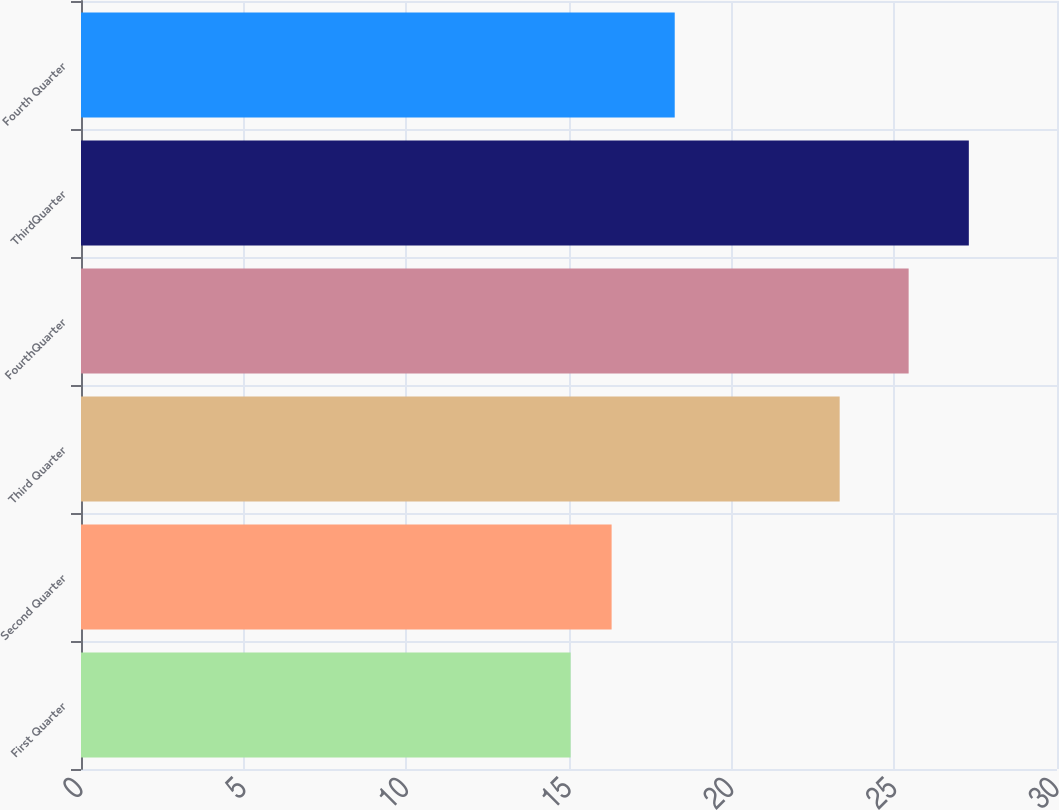<chart> <loc_0><loc_0><loc_500><loc_500><bar_chart><fcel>First Quarter<fcel>Second Quarter<fcel>Third Quarter<fcel>FourthQuarter<fcel>ThirdQuarter<fcel>Fourth Quarter<nl><fcel>15.05<fcel>16.31<fcel>23.32<fcel>25.44<fcel>27.29<fcel>18.25<nl></chart> 